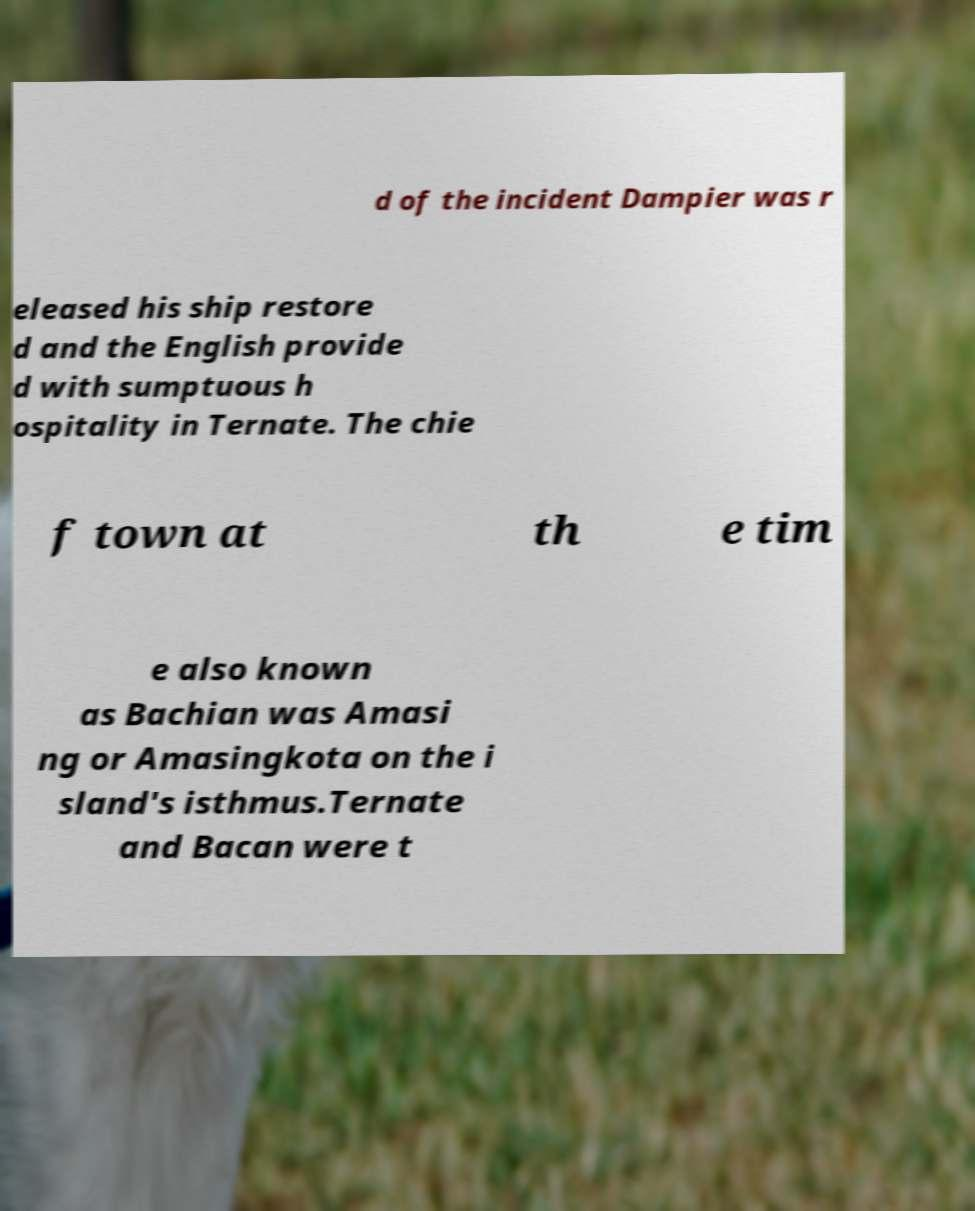Can you read and provide the text displayed in the image?This photo seems to have some interesting text. Can you extract and type it out for me? d of the incident Dampier was r eleased his ship restore d and the English provide d with sumptuous h ospitality in Ternate. The chie f town at th e tim e also known as Bachian was Amasi ng or Amasingkota on the i sland's isthmus.Ternate and Bacan were t 